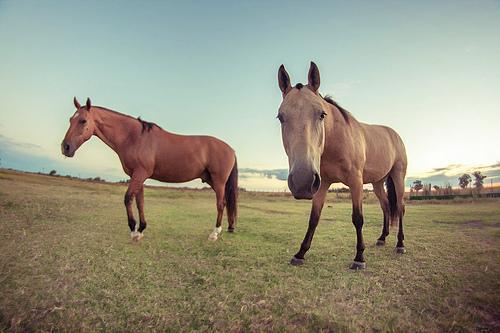How many horses are there?
Give a very brief answer. 2. How many legs does each horse have?
Give a very brief answer. 4. 